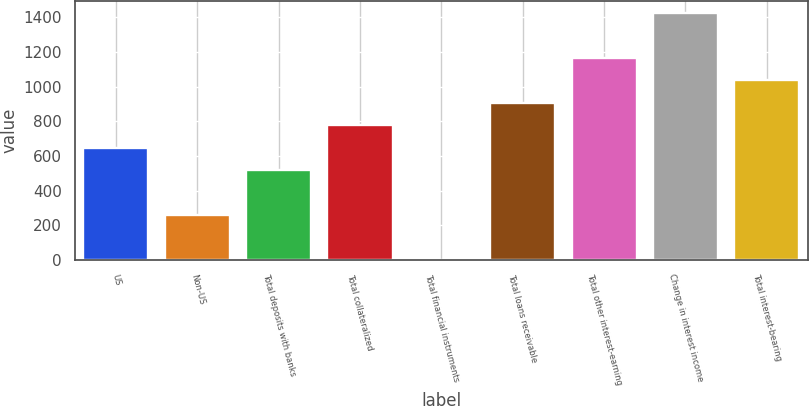Convert chart. <chart><loc_0><loc_0><loc_500><loc_500><bar_chart><fcel>US<fcel>Non-US<fcel>Total deposits with banks<fcel>Total collateralized<fcel>Total financial instruments<fcel>Total loans receivable<fcel>Total other interest-earning<fcel>Change in interest income<fcel>Total interest-bearing<nl><fcel>648<fcel>259.8<fcel>518.6<fcel>777.4<fcel>1<fcel>906.8<fcel>1165.6<fcel>1424.4<fcel>1036.2<nl></chart> 